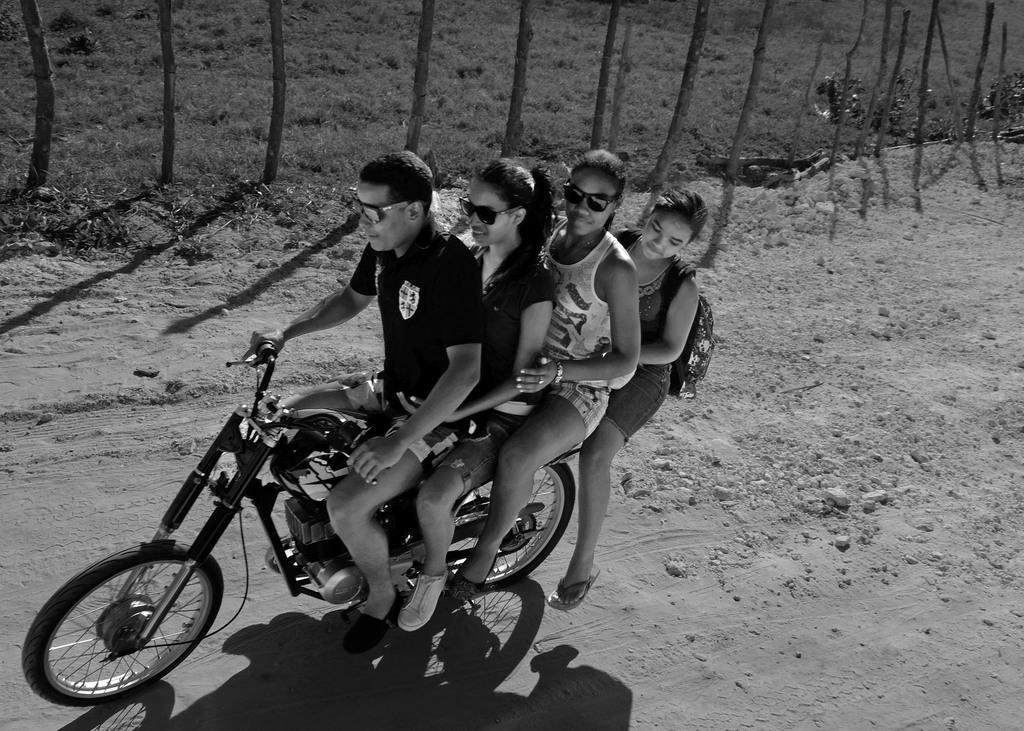Could you give a brief overview of what you see in this image? The four persons are sitting on a motorcycle. The three persons are wearing a spectacles. The front person is driving a motorcycle and the last person is wearing bag. We can see in the background trees,grass and stones. 